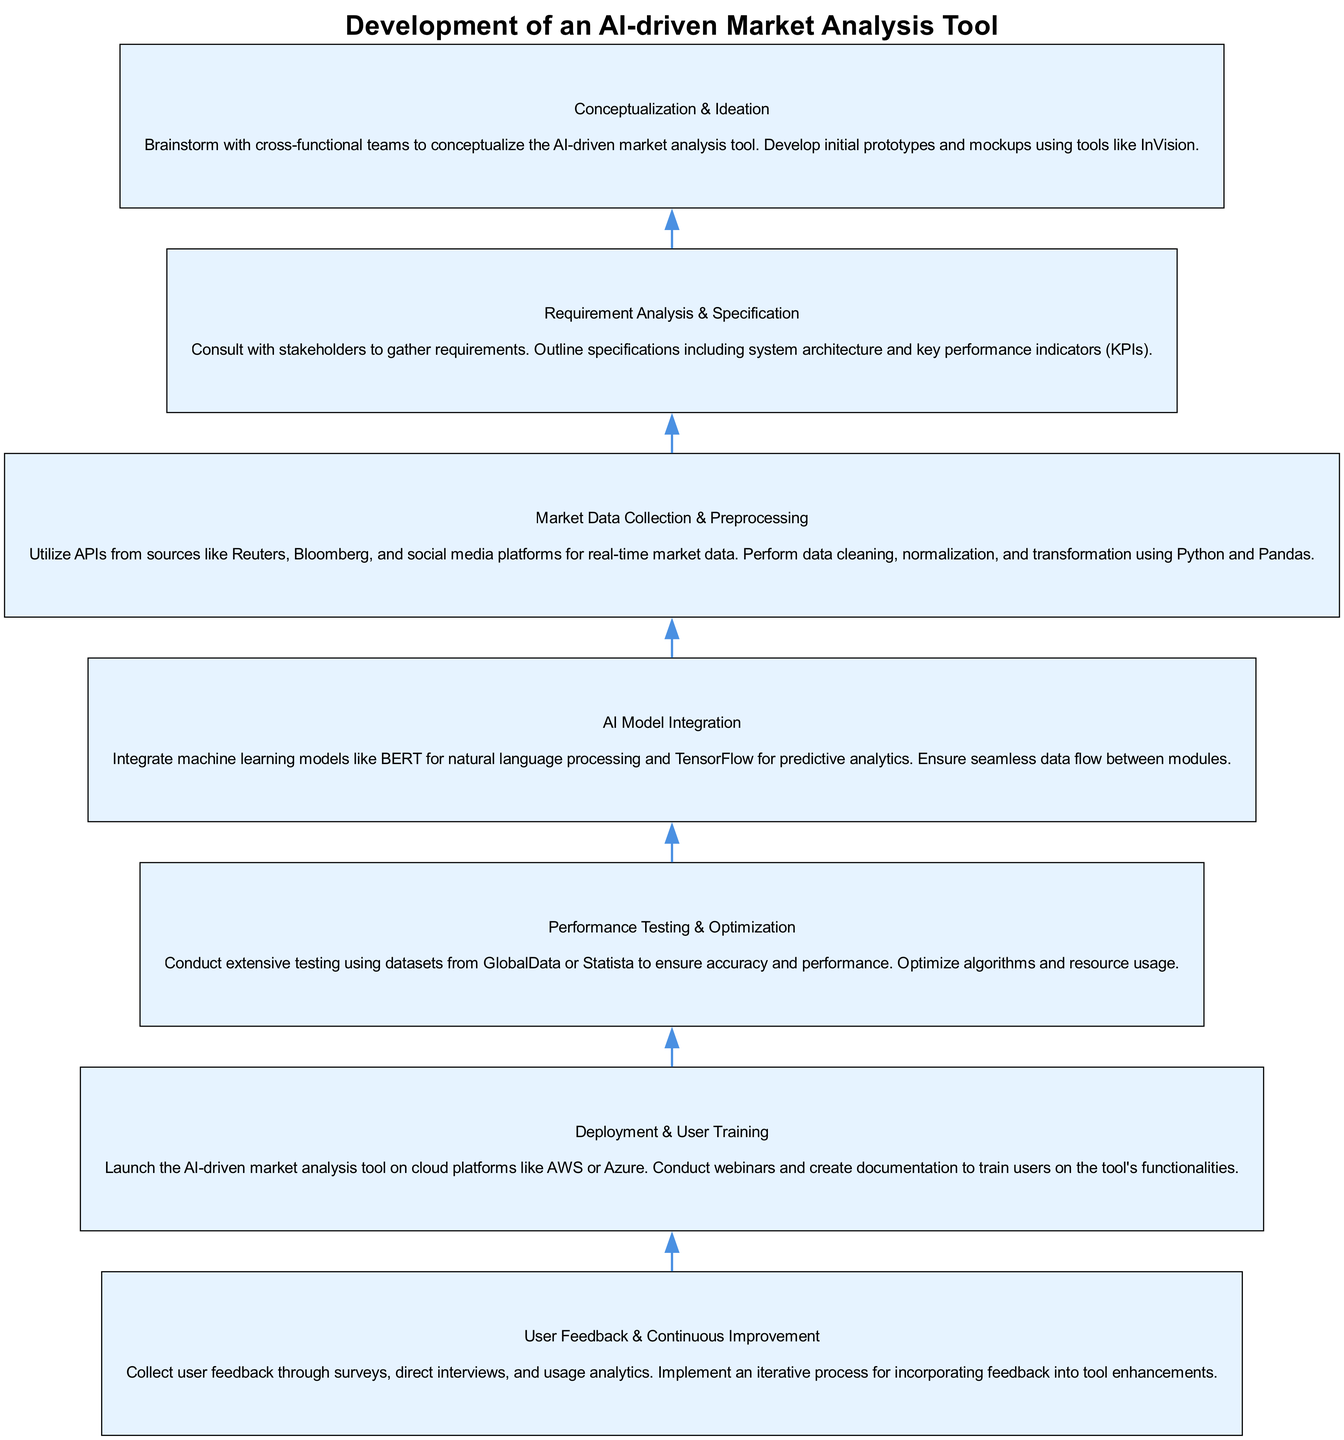What is the final stage in the diagram? The final stage in the flow chart is the "User Feedback & Continuous Improvement" stage. This is the top node, and no further nodes follow it, indicating it's the last step in the process.
Answer: User Feedback & Continuous Improvement How many stages are in the diagram? There are a total of seven stages presented in the flow chart, each representing a step in the development process of the AI-driven market analysis tool.
Answer: Seven What stage precedes the "AI Model Integration" stage? The stage that comes before "AI Model Integration" is "Market Data Collection & Preprocessing." This can be determined by looking at the flow from bottom to up in the diagram.
Answer: Market Data Collection & Preprocessing What is the purpose of the "Requirement Analysis & Specification" stage? This stage focuses on consulting with stakeholders to gather requirements and outline specifications such as system architecture and performance indicators. It involves understanding what is needed before proceeding further in development.
Answer: Gathering requirements How does "User Feedback & Continuous Improvement" relate to "Deployment & User Training"? "User Feedback & Continuous Improvement" follows "Deployment & User Training" in the flow chart, indicating that after the tool is deployed and users are trained, feedback is collected to improve the tool. This shows a cyclical relationship where deployment initiates feedback.
Answer: It follows and builds upon it Which stage utilizes APIs for data collection? The stage that utilizes APIs for data collection is "Market Data Collection & Preprocessing." This is explicitly mentioned in the description of that stage in the diagram.
Answer: Market Data Collection & Preprocessing What is the initial stage of the process? The initial stage of the process is "Conceptualization & Ideation," which serves as the starting point where brainstorming and initial prototype development occurs. This stage lays the foundation for all subsequent stages.
Answer: Conceptualization & Ideation What type of algorithms are optimized in the "Performance Testing & Optimization" stage? The algorithms optimized in this stage include machine learning models such as BERT and tools for predictive analytics like TensorFlow. The stage focuses on ensuring both accuracy and performance of these algorithms.
Answer: Machine learning algorithms What is the main focus of the "Deployment & User Training" stage? The main focus of this stage is to launch the AI-driven market analysis tool and provide training to users through webinars and documentation. This effectively prepares users to utilize the tool successfully after its launch.
Answer: Training users 